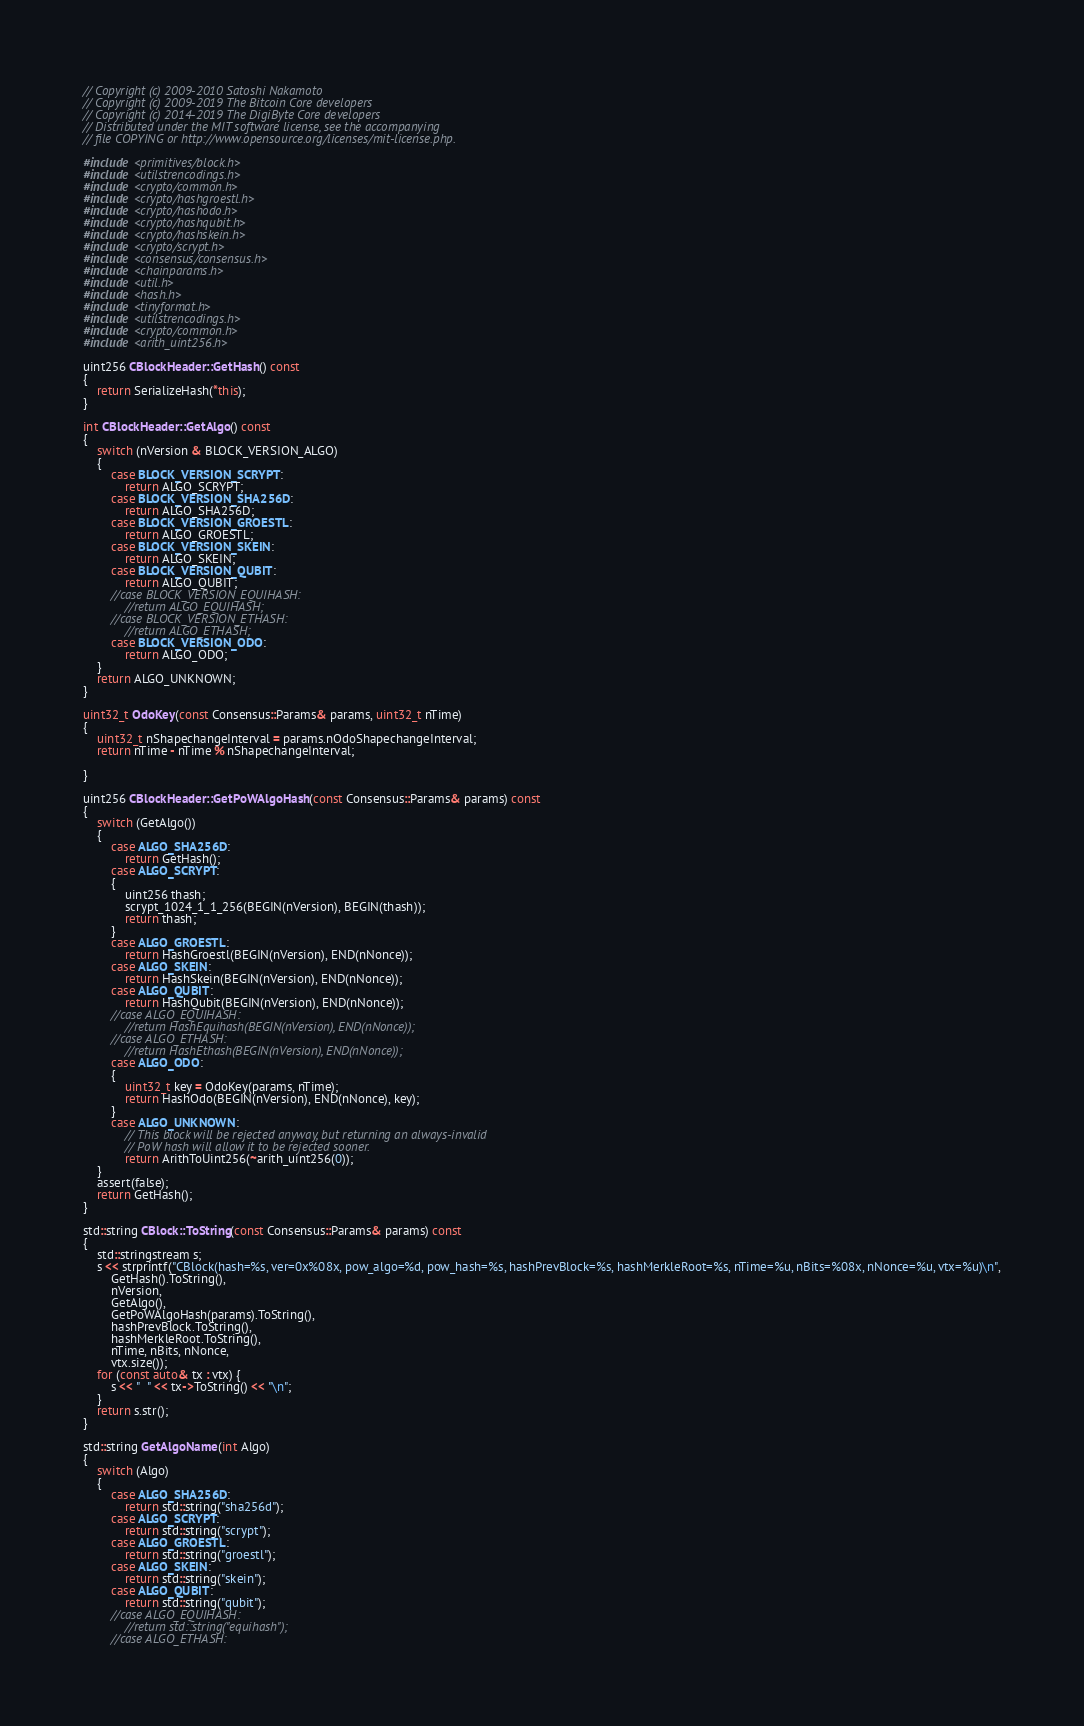Convert code to text. <code><loc_0><loc_0><loc_500><loc_500><_C++_>// Copyright (c) 2009-2010 Satoshi Nakamoto
// Copyright (c) 2009-2019 The Bitcoin Core developers
// Copyright (c) 2014-2019 The DigiByte Core developers
// Distributed under the MIT software license, see the accompanying
// file COPYING or http://www.opensource.org/licenses/mit-license.php.

#include <primitives/block.h>
#include <utilstrencodings.h>
#include <crypto/common.h>
#include <crypto/hashgroestl.h>
#include <crypto/hashodo.h>
#include <crypto/hashqubit.h>
#include <crypto/hashskein.h>
#include <crypto/scrypt.h>
#include <consensus/consensus.h>
#include <chainparams.h>
#include <util.h>
#include <hash.h>
#include <tinyformat.h>
#include <utilstrencodings.h>
#include <crypto/common.h>
#include <arith_uint256.h>

uint256 CBlockHeader::GetHash() const
{
    return SerializeHash(*this);
}

int CBlockHeader::GetAlgo() const
{
    switch (nVersion & BLOCK_VERSION_ALGO)
    {
        case BLOCK_VERSION_SCRYPT:
            return ALGO_SCRYPT;
        case BLOCK_VERSION_SHA256D:
            return ALGO_SHA256D;
        case BLOCK_VERSION_GROESTL:
            return ALGO_GROESTL;
        case BLOCK_VERSION_SKEIN:
            return ALGO_SKEIN;
        case BLOCK_VERSION_QUBIT:
            return ALGO_QUBIT;
        //case BLOCK_VERSION_EQUIHASH:
            //return ALGO_EQUIHASH;
        //case BLOCK_VERSION_ETHASH:
            //return ALGO_ETHASH;
        case BLOCK_VERSION_ODO:
            return ALGO_ODO;
    }
    return ALGO_UNKNOWN;
}

uint32_t OdoKey(const Consensus::Params& params, uint32_t nTime)
{
    uint32_t nShapechangeInterval = params.nOdoShapechangeInterval;
    return nTime - nTime % nShapechangeInterval;

}

uint256 CBlockHeader::GetPoWAlgoHash(const Consensus::Params& params) const
{
    switch (GetAlgo())
    {
        case ALGO_SHA256D:
            return GetHash();
        case ALGO_SCRYPT:
        {
            uint256 thash;
            scrypt_1024_1_1_256(BEGIN(nVersion), BEGIN(thash));
            return thash;
        }
        case ALGO_GROESTL:
            return HashGroestl(BEGIN(nVersion), END(nNonce));
        case ALGO_SKEIN:
            return HashSkein(BEGIN(nVersion), END(nNonce));
        case ALGO_QUBIT:
            return HashQubit(BEGIN(nVersion), END(nNonce));
        //case ALGO_EQUIHASH:
            //return HashEquihash(BEGIN(nVersion), END(nNonce));
        //case ALGO_ETHASH:
            //return HashEthash(BEGIN(nVersion), END(nNonce));
        case ALGO_ODO:
        {
            uint32_t key = OdoKey(params, nTime);
            return HashOdo(BEGIN(nVersion), END(nNonce), key);
        }
        case ALGO_UNKNOWN:
            // This block will be rejected anyway, but returning an always-invalid
            // PoW hash will allow it to be rejected sooner.
            return ArithToUint256(~arith_uint256(0));
    }
    assert(false);
    return GetHash();
}

std::string CBlock::ToString(const Consensus::Params& params) const
{
    std::stringstream s;
    s << strprintf("CBlock(hash=%s, ver=0x%08x, pow_algo=%d, pow_hash=%s, hashPrevBlock=%s, hashMerkleRoot=%s, nTime=%u, nBits=%08x, nNonce=%u, vtx=%u)\n",
        GetHash().ToString(),
        nVersion,
        GetAlgo(),
        GetPoWAlgoHash(params).ToString(),
        hashPrevBlock.ToString(),
        hashMerkleRoot.ToString(),
        nTime, nBits, nNonce,
        vtx.size());
    for (const auto& tx : vtx) {
        s << "  " << tx->ToString() << "\n";
    }
    return s.str();
}

std::string GetAlgoName(int Algo)
{
    switch (Algo)
    {
        case ALGO_SHA256D:
            return std::string("sha256d");
        case ALGO_SCRYPT:
            return std::string("scrypt");
        case ALGO_GROESTL:
            return std::string("groestl");
        case ALGO_SKEIN:
            return std::string("skein");
        case ALGO_QUBIT:
            return std::string("qubit");
        //case ALGO_EQUIHASH:
            //return std::string("equihash");
        //case ALGO_ETHASH:</code> 